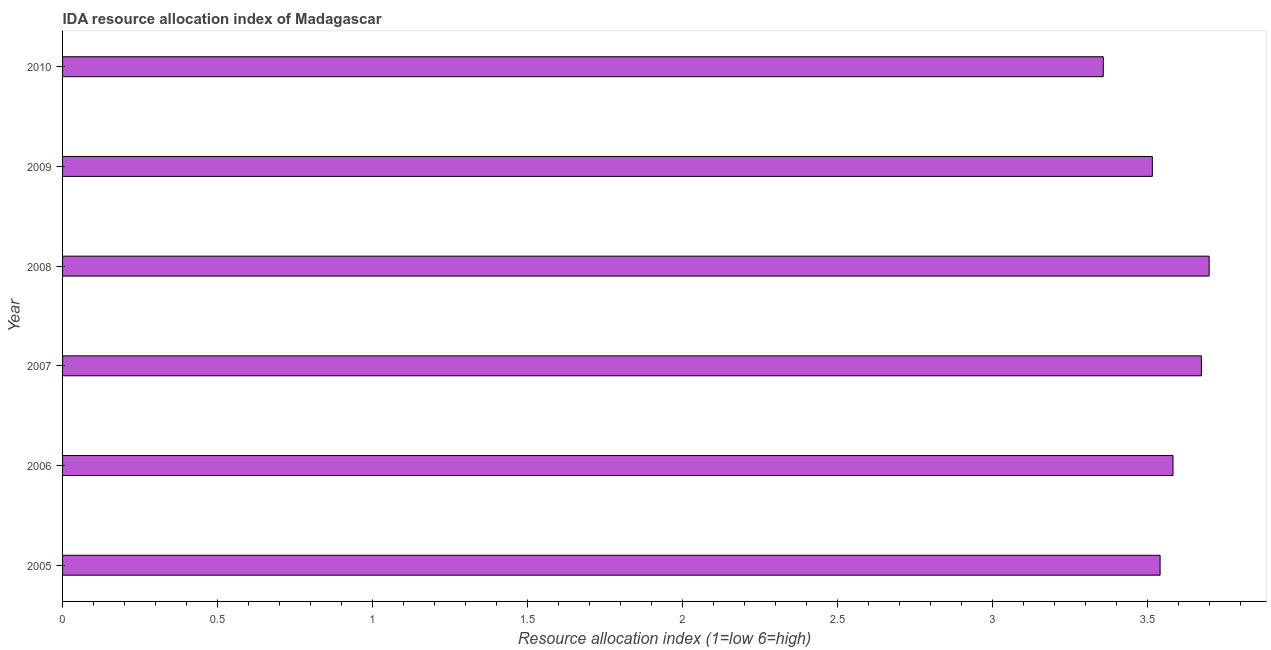Does the graph contain any zero values?
Your answer should be very brief. No. Does the graph contain grids?
Offer a terse response. No. What is the title of the graph?
Offer a terse response. IDA resource allocation index of Madagascar. What is the label or title of the X-axis?
Offer a very short reply. Resource allocation index (1=low 6=high). What is the label or title of the Y-axis?
Provide a succinct answer. Year. What is the ida resource allocation index in 2007?
Offer a terse response. 3.67. Across all years, what is the maximum ida resource allocation index?
Offer a very short reply. 3.7. Across all years, what is the minimum ida resource allocation index?
Your response must be concise. 3.36. In which year was the ida resource allocation index maximum?
Your response must be concise. 2008. What is the sum of the ida resource allocation index?
Give a very brief answer. 21.38. What is the difference between the ida resource allocation index in 2008 and 2009?
Keep it short and to the point. 0.18. What is the average ida resource allocation index per year?
Provide a short and direct response. 3.56. What is the median ida resource allocation index?
Your answer should be compact. 3.56. Do a majority of the years between 2009 and 2006 (inclusive) have ida resource allocation index greater than 0.7 ?
Give a very brief answer. Yes. What is the ratio of the ida resource allocation index in 2006 to that in 2007?
Your response must be concise. 0.97. Is the ida resource allocation index in 2007 less than that in 2010?
Provide a succinct answer. No. Is the difference between the ida resource allocation index in 2007 and 2010 greater than the difference between any two years?
Provide a short and direct response. No. What is the difference between the highest and the second highest ida resource allocation index?
Your response must be concise. 0.03. Is the sum of the ida resource allocation index in 2005 and 2010 greater than the maximum ida resource allocation index across all years?
Your answer should be compact. Yes. What is the difference between the highest and the lowest ida resource allocation index?
Give a very brief answer. 0.34. In how many years, is the ida resource allocation index greater than the average ida resource allocation index taken over all years?
Your response must be concise. 3. How many bars are there?
Your response must be concise. 6. Are all the bars in the graph horizontal?
Ensure brevity in your answer.  Yes. What is the difference between two consecutive major ticks on the X-axis?
Your answer should be compact. 0.5. What is the Resource allocation index (1=low 6=high) in 2005?
Make the answer very short. 3.54. What is the Resource allocation index (1=low 6=high) of 2006?
Your answer should be very brief. 3.58. What is the Resource allocation index (1=low 6=high) in 2007?
Offer a terse response. 3.67. What is the Resource allocation index (1=low 6=high) of 2008?
Make the answer very short. 3.7. What is the Resource allocation index (1=low 6=high) of 2009?
Your answer should be very brief. 3.52. What is the Resource allocation index (1=low 6=high) of 2010?
Ensure brevity in your answer.  3.36. What is the difference between the Resource allocation index (1=low 6=high) in 2005 and 2006?
Your answer should be very brief. -0.04. What is the difference between the Resource allocation index (1=low 6=high) in 2005 and 2007?
Offer a terse response. -0.13. What is the difference between the Resource allocation index (1=low 6=high) in 2005 and 2008?
Provide a short and direct response. -0.16. What is the difference between the Resource allocation index (1=low 6=high) in 2005 and 2009?
Provide a short and direct response. 0.03. What is the difference between the Resource allocation index (1=low 6=high) in 2005 and 2010?
Offer a terse response. 0.18. What is the difference between the Resource allocation index (1=low 6=high) in 2006 and 2007?
Make the answer very short. -0.09. What is the difference between the Resource allocation index (1=low 6=high) in 2006 and 2008?
Provide a succinct answer. -0.12. What is the difference between the Resource allocation index (1=low 6=high) in 2006 and 2009?
Your answer should be compact. 0.07. What is the difference between the Resource allocation index (1=low 6=high) in 2006 and 2010?
Your answer should be very brief. 0.23. What is the difference between the Resource allocation index (1=low 6=high) in 2007 and 2008?
Your answer should be compact. -0.03. What is the difference between the Resource allocation index (1=low 6=high) in 2007 and 2009?
Offer a very short reply. 0.16. What is the difference between the Resource allocation index (1=low 6=high) in 2007 and 2010?
Provide a succinct answer. 0.32. What is the difference between the Resource allocation index (1=low 6=high) in 2008 and 2009?
Your answer should be very brief. 0.18. What is the difference between the Resource allocation index (1=low 6=high) in 2008 and 2010?
Keep it short and to the point. 0.34. What is the difference between the Resource allocation index (1=low 6=high) in 2009 and 2010?
Your answer should be compact. 0.16. What is the ratio of the Resource allocation index (1=low 6=high) in 2005 to that in 2008?
Give a very brief answer. 0.96. What is the ratio of the Resource allocation index (1=low 6=high) in 2005 to that in 2010?
Offer a terse response. 1.05. What is the ratio of the Resource allocation index (1=low 6=high) in 2006 to that in 2010?
Ensure brevity in your answer.  1.07. What is the ratio of the Resource allocation index (1=low 6=high) in 2007 to that in 2008?
Make the answer very short. 0.99. What is the ratio of the Resource allocation index (1=low 6=high) in 2007 to that in 2009?
Make the answer very short. 1.04. What is the ratio of the Resource allocation index (1=low 6=high) in 2007 to that in 2010?
Ensure brevity in your answer.  1.09. What is the ratio of the Resource allocation index (1=low 6=high) in 2008 to that in 2009?
Your response must be concise. 1.05. What is the ratio of the Resource allocation index (1=low 6=high) in 2008 to that in 2010?
Provide a succinct answer. 1.1. What is the ratio of the Resource allocation index (1=low 6=high) in 2009 to that in 2010?
Your response must be concise. 1.05. 